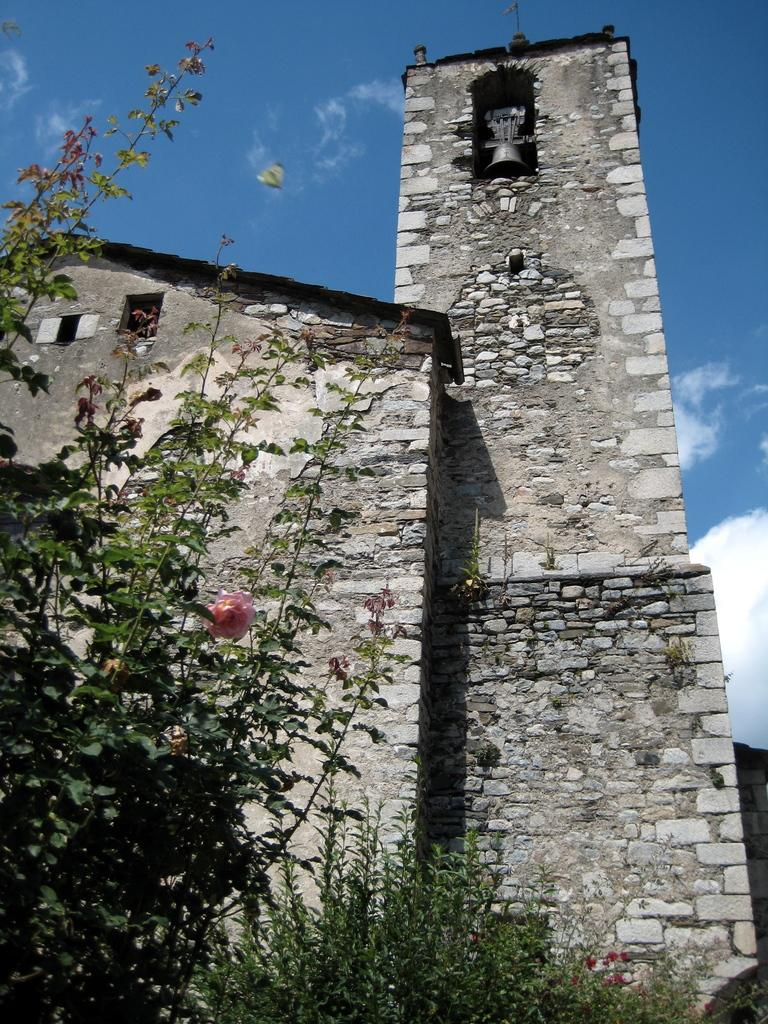What type of vegetation is on the left side of the image? There are plants on the left side of the image. What structure can be seen in the background of the image? There is a house in the background of the image. What is visible at the top of the image? The sky is visible in the image. What type of plantation can be seen in the image? There is no plantation present in the image; it features plants on the left side and a house in the background. What title is given to the house in the image? There is no title provided for the house in the image. 